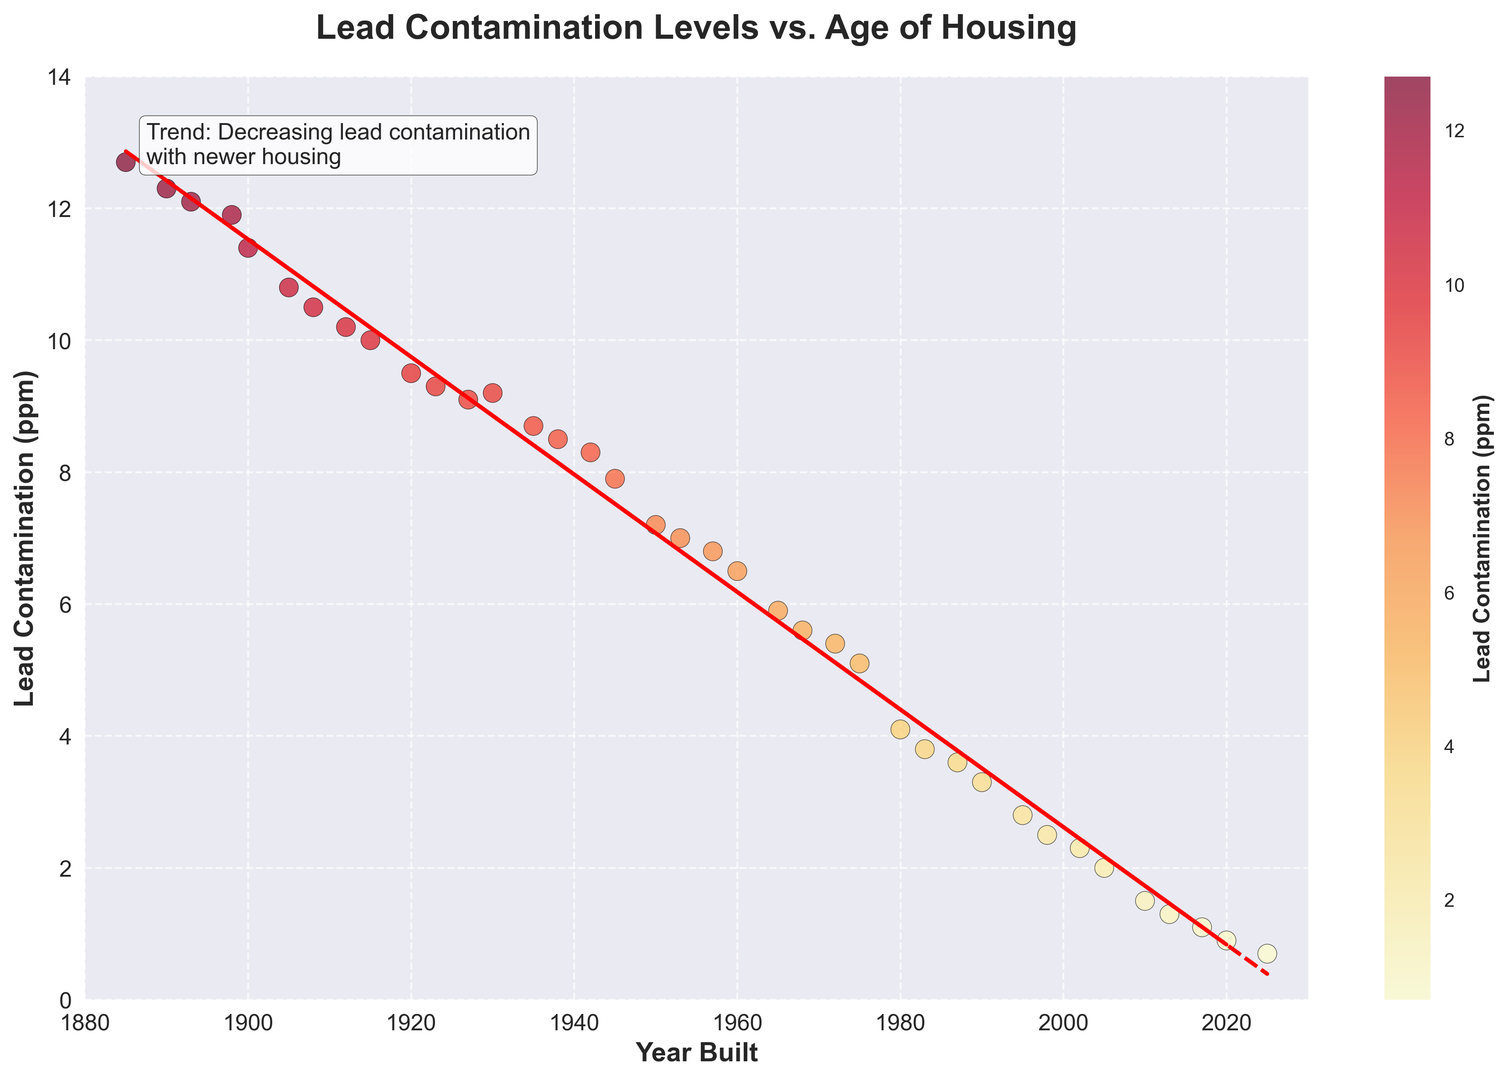What trend can be observed from the plot regarding the relationship between the year built and lead contamination levels? The plot shows that lead contamination levels decrease as the year built increases. This is indicated by the negative slope of the trendline and the text annotation that states "Trend: Decreasing lead contamination with newer housing."
Answer: Decreasing lead contamination with newer housing Which year built had the highest lead contamination level, and what was the contamination level? The data point with the highest lead contamination level is around the year 1885 with a contamination level of approximately 12.7 ppm, as shown in the upper left section of the scatter plot.
Answer: 1885, 12.7 ppm Are houses built after the year 2000 generally safer in terms of lead contamination compared to those built before 1950? Visually comparing the scatter plot, houses built after the year 2000 show significantly lower lead contamination levels (approximately 1.5 ppm or lower) compared to those built before 1950, which generally show levels around 7 ppm to 12.7 ppm.
Answer: Yes What is the approximate average lead contamination level for houses built between 1900 and 1950? To calculate the average, sum the lead contamination levels for houses built between 1900 and 1950 and then divide by the number of data points:
(11.4 + 10.8 + 10.5 + 10.2 + 10.0 + 9.5 + 9.3 + 9.2 + 8.7 + 8.5 + 8.3 + 7.9 + 7.2) / 13 = 9.38 ppm
Answer: 9.38 ppm Which year saw the greatest reduction in lead contamination levels compared to 5 years prior? Comparing the reductions over 5-year intervals from the plot, the steepest slope appears between the years 1950 to 1955. Therefore, the year 1955 saw the greatest reduction compared to 1950.
Answer: 1955 What is the range of lead contamination levels observed in the plot? The range can be calculated by subtracting the smallest contamination level from the largest:
12.7 ppm (maximum) - 0.7 ppm (minimum) = 12 ppm
Answer: 12 ppm Describe the visual difference in color between houses built in the late 1800s and those built after the year 2000. The scatter plot uses a yellow to red color gradient, where higher lead contamination levels are indicated by darker (red) colors. Houses built in the late 1800s appear in darker red hues, while those built after 2000 are in lighter yellow or almost white colors, indicating lower contamination levels.
Answer: Darker red for late 1800s, lighter yellow/white for post-2000 